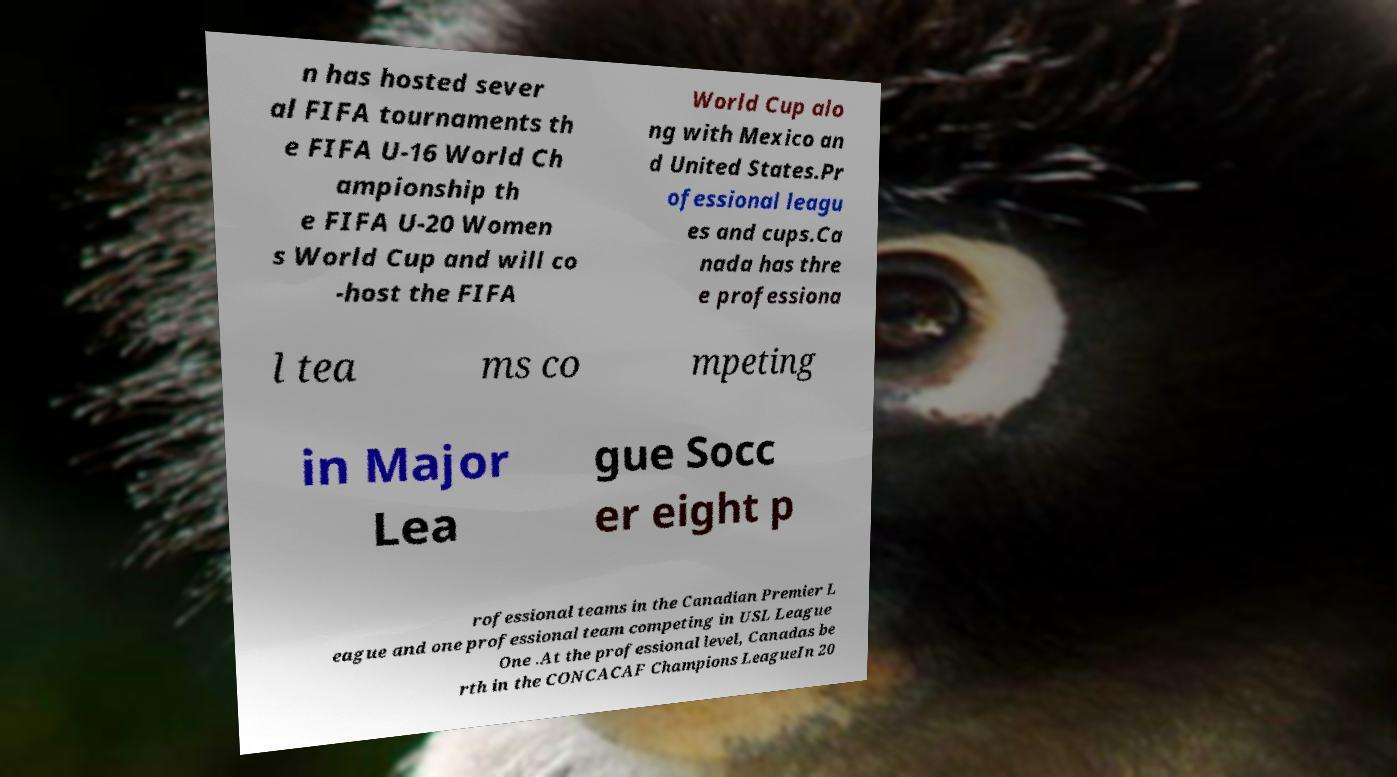I need the written content from this picture converted into text. Can you do that? n has hosted sever al FIFA tournaments th e FIFA U-16 World Ch ampionship th e FIFA U-20 Women s World Cup and will co -host the FIFA World Cup alo ng with Mexico an d United States.Pr ofessional leagu es and cups.Ca nada has thre e professiona l tea ms co mpeting in Major Lea gue Socc er eight p rofessional teams in the Canadian Premier L eague and one professional team competing in USL League One .At the professional level, Canadas be rth in the CONCACAF Champions LeagueIn 20 